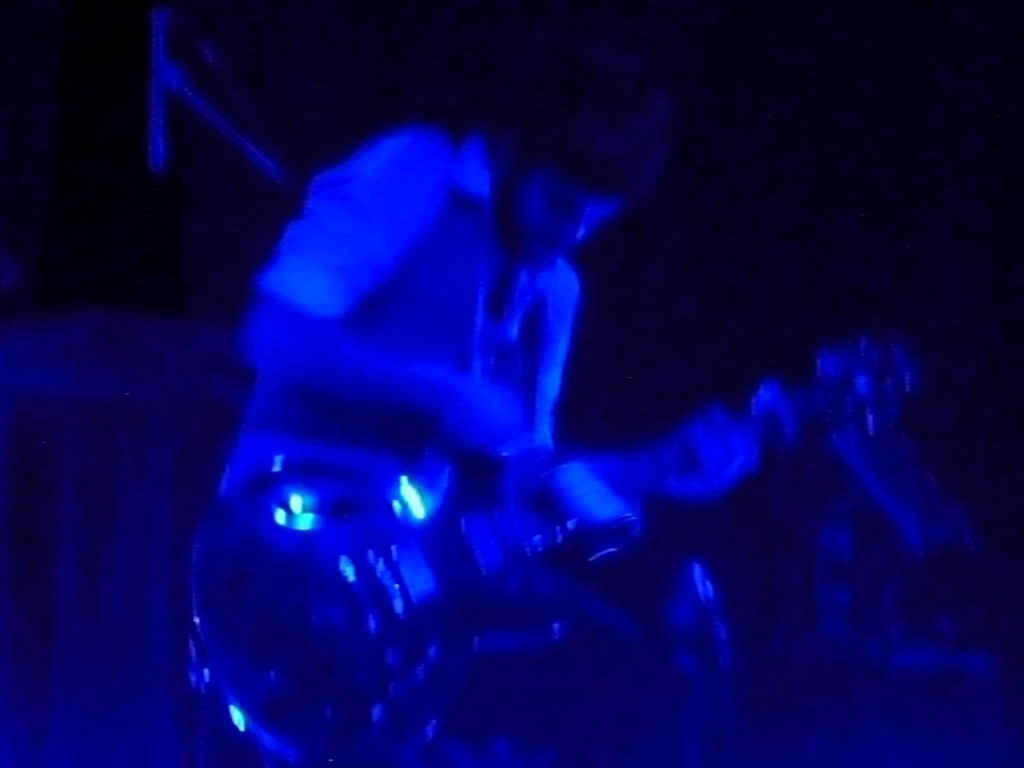Despite the low exposure, can you infer anything about the individual in the image? While details are difficult to discern due to the low exposure, the silhouette and posture of the individual suggest that they are playing a guitar. The stance and potential movement indicate a sense of involvement and expression typically associated with a musician immersed in their performance. Could the choice of lighting be intentional, and if so, what might it convey artistically? Yes, the choice of such dramatic lighting is likely intentional. Artistically, it can convey the raw emotion and energy of live performances, creating a more immersive experience for the audience. The isolating effect of the blue envelops the musician in a private world, highlighting the intimacy between the artist and their art. 